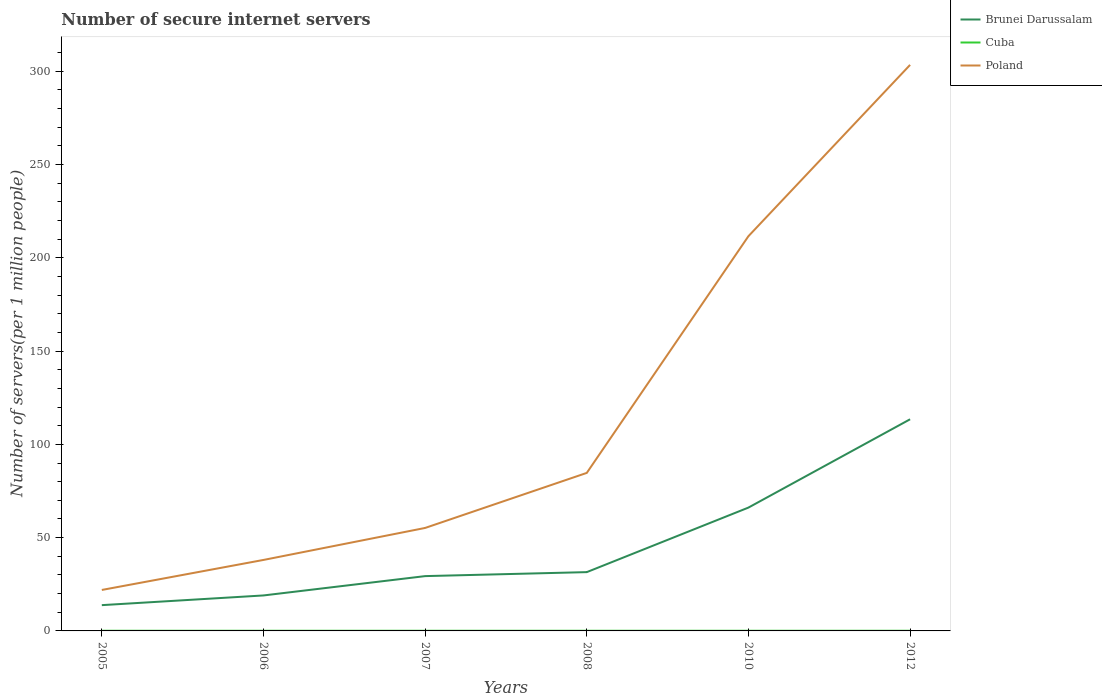Is the number of lines equal to the number of legend labels?
Give a very brief answer. Yes. Across all years, what is the maximum number of secure internet servers in Cuba?
Ensure brevity in your answer.  0.09. In which year was the number of secure internet servers in Brunei Darussalam maximum?
Offer a very short reply. 2005. What is the total number of secure internet servers in Poland in the graph?
Give a very brief answer. -91.81. What is the difference between the highest and the second highest number of secure internet servers in Brunei Darussalam?
Ensure brevity in your answer.  99.62. What is the difference between the highest and the lowest number of secure internet servers in Cuba?
Ensure brevity in your answer.  4. Is the number of secure internet servers in Cuba strictly greater than the number of secure internet servers in Poland over the years?
Ensure brevity in your answer.  Yes. Does the graph contain any zero values?
Provide a succinct answer. No. Where does the legend appear in the graph?
Ensure brevity in your answer.  Top right. How are the legend labels stacked?
Ensure brevity in your answer.  Vertical. What is the title of the graph?
Offer a terse response. Number of secure internet servers. What is the label or title of the X-axis?
Make the answer very short. Years. What is the label or title of the Y-axis?
Ensure brevity in your answer.  Number of servers(per 1 million people). What is the Number of servers(per 1 million people) of Brunei Darussalam in 2005?
Provide a succinct answer. 13.82. What is the Number of servers(per 1 million people) in Cuba in 2005?
Give a very brief answer. 0.09. What is the Number of servers(per 1 million people) of Poland in 2005?
Your response must be concise. 21.96. What is the Number of servers(per 1 million people) in Brunei Darussalam in 2006?
Your answer should be compact. 19.01. What is the Number of servers(per 1 million people) in Cuba in 2006?
Provide a short and direct response. 0.09. What is the Number of servers(per 1 million people) in Poland in 2006?
Ensure brevity in your answer.  38.04. What is the Number of servers(per 1 million people) of Brunei Darussalam in 2007?
Ensure brevity in your answer.  29.38. What is the Number of servers(per 1 million people) in Cuba in 2007?
Offer a very short reply. 0.09. What is the Number of servers(per 1 million people) of Poland in 2007?
Your answer should be very brief. 55.19. What is the Number of servers(per 1 million people) in Brunei Darussalam in 2008?
Your answer should be very brief. 31.51. What is the Number of servers(per 1 million people) in Cuba in 2008?
Make the answer very short. 0.09. What is the Number of servers(per 1 million people) of Poland in 2008?
Give a very brief answer. 84.69. What is the Number of servers(per 1 million people) of Brunei Darussalam in 2010?
Ensure brevity in your answer.  66.11. What is the Number of servers(per 1 million people) of Cuba in 2010?
Offer a terse response. 0.09. What is the Number of servers(per 1 million people) in Poland in 2010?
Keep it short and to the point. 211.58. What is the Number of servers(per 1 million people) of Brunei Darussalam in 2012?
Give a very brief answer. 113.44. What is the Number of servers(per 1 million people) of Cuba in 2012?
Your response must be concise. 0.09. What is the Number of servers(per 1 million people) of Poland in 2012?
Keep it short and to the point. 303.39. Across all years, what is the maximum Number of servers(per 1 million people) in Brunei Darussalam?
Keep it short and to the point. 113.44. Across all years, what is the maximum Number of servers(per 1 million people) in Cuba?
Offer a terse response. 0.09. Across all years, what is the maximum Number of servers(per 1 million people) in Poland?
Provide a succinct answer. 303.39. Across all years, what is the minimum Number of servers(per 1 million people) in Brunei Darussalam?
Keep it short and to the point. 13.82. Across all years, what is the minimum Number of servers(per 1 million people) of Cuba?
Provide a short and direct response. 0.09. Across all years, what is the minimum Number of servers(per 1 million people) of Poland?
Offer a very short reply. 21.96. What is the total Number of servers(per 1 million people) of Brunei Darussalam in the graph?
Offer a terse response. 273.26. What is the total Number of servers(per 1 million people) in Cuba in the graph?
Your response must be concise. 0.53. What is the total Number of servers(per 1 million people) of Poland in the graph?
Your answer should be compact. 714.85. What is the difference between the Number of servers(per 1 million people) of Brunei Darussalam in 2005 and that in 2006?
Provide a short and direct response. -5.2. What is the difference between the Number of servers(per 1 million people) in Cuba in 2005 and that in 2006?
Offer a very short reply. 0. What is the difference between the Number of servers(per 1 million people) in Poland in 2005 and that in 2006?
Keep it short and to the point. -16.09. What is the difference between the Number of servers(per 1 million people) in Brunei Darussalam in 2005 and that in 2007?
Provide a short and direct response. -15.56. What is the difference between the Number of servers(per 1 million people) in Cuba in 2005 and that in 2007?
Ensure brevity in your answer.  0. What is the difference between the Number of servers(per 1 million people) in Poland in 2005 and that in 2007?
Your answer should be compact. -33.24. What is the difference between the Number of servers(per 1 million people) in Brunei Darussalam in 2005 and that in 2008?
Keep it short and to the point. -17.7. What is the difference between the Number of servers(per 1 million people) of Cuba in 2005 and that in 2008?
Your answer should be compact. 0. What is the difference between the Number of servers(per 1 million people) of Poland in 2005 and that in 2008?
Make the answer very short. -62.74. What is the difference between the Number of servers(per 1 million people) in Brunei Darussalam in 2005 and that in 2010?
Your answer should be compact. -52.29. What is the difference between the Number of servers(per 1 million people) of Poland in 2005 and that in 2010?
Offer a very short reply. -189.62. What is the difference between the Number of servers(per 1 million people) of Brunei Darussalam in 2005 and that in 2012?
Your answer should be compact. -99.62. What is the difference between the Number of servers(per 1 million people) in Cuba in 2005 and that in 2012?
Your answer should be compact. 0. What is the difference between the Number of servers(per 1 million people) of Poland in 2005 and that in 2012?
Your answer should be very brief. -281.43. What is the difference between the Number of servers(per 1 million people) in Brunei Darussalam in 2006 and that in 2007?
Make the answer very short. -10.36. What is the difference between the Number of servers(per 1 million people) in Poland in 2006 and that in 2007?
Provide a short and direct response. -17.15. What is the difference between the Number of servers(per 1 million people) of Brunei Darussalam in 2006 and that in 2008?
Provide a succinct answer. -12.5. What is the difference between the Number of servers(per 1 million people) of Poland in 2006 and that in 2008?
Offer a terse response. -46.65. What is the difference between the Number of servers(per 1 million people) of Brunei Darussalam in 2006 and that in 2010?
Make the answer very short. -47.09. What is the difference between the Number of servers(per 1 million people) of Cuba in 2006 and that in 2010?
Your response must be concise. 0. What is the difference between the Number of servers(per 1 million people) of Poland in 2006 and that in 2010?
Your answer should be very brief. -173.53. What is the difference between the Number of servers(per 1 million people) in Brunei Darussalam in 2006 and that in 2012?
Give a very brief answer. -94.42. What is the difference between the Number of servers(per 1 million people) of Poland in 2006 and that in 2012?
Ensure brevity in your answer.  -265.35. What is the difference between the Number of servers(per 1 million people) in Brunei Darussalam in 2007 and that in 2008?
Your response must be concise. -2.14. What is the difference between the Number of servers(per 1 million people) of Cuba in 2007 and that in 2008?
Keep it short and to the point. 0. What is the difference between the Number of servers(per 1 million people) of Poland in 2007 and that in 2008?
Keep it short and to the point. -29.5. What is the difference between the Number of servers(per 1 million people) of Brunei Darussalam in 2007 and that in 2010?
Your answer should be very brief. -36.73. What is the difference between the Number of servers(per 1 million people) of Poland in 2007 and that in 2010?
Your response must be concise. -156.38. What is the difference between the Number of servers(per 1 million people) in Brunei Darussalam in 2007 and that in 2012?
Offer a terse response. -84.06. What is the difference between the Number of servers(per 1 million people) of Poland in 2007 and that in 2012?
Ensure brevity in your answer.  -248.2. What is the difference between the Number of servers(per 1 million people) in Brunei Darussalam in 2008 and that in 2010?
Provide a short and direct response. -34.59. What is the difference between the Number of servers(per 1 million people) in Cuba in 2008 and that in 2010?
Keep it short and to the point. 0. What is the difference between the Number of servers(per 1 million people) of Poland in 2008 and that in 2010?
Ensure brevity in your answer.  -126.88. What is the difference between the Number of servers(per 1 million people) in Brunei Darussalam in 2008 and that in 2012?
Ensure brevity in your answer.  -81.92. What is the difference between the Number of servers(per 1 million people) in Poland in 2008 and that in 2012?
Ensure brevity in your answer.  -218.7. What is the difference between the Number of servers(per 1 million people) of Brunei Darussalam in 2010 and that in 2012?
Your answer should be compact. -47.33. What is the difference between the Number of servers(per 1 million people) in Cuba in 2010 and that in 2012?
Your response must be concise. 0. What is the difference between the Number of servers(per 1 million people) of Poland in 2010 and that in 2012?
Make the answer very short. -91.81. What is the difference between the Number of servers(per 1 million people) in Brunei Darussalam in 2005 and the Number of servers(per 1 million people) in Cuba in 2006?
Give a very brief answer. 13.73. What is the difference between the Number of servers(per 1 million people) of Brunei Darussalam in 2005 and the Number of servers(per 1 million people) of Poland in 2006?
Give a very brief answer. -24.23. What is the difference between the Number of servers(per 1 million people) of Cuba in 2005 and the Number of servers(per 1 million people) of Poland in 2006?
Offer a very short reply. -37.95. What is the difference between the Number of servers(per 1 million people) in Brunei Darussalam in 2005 and the Number of servers(per 1 million people) in Cuba in 2007?
Offer a terse response. 13.73. What is the difference between the Number of servers(per 1 million people) of Brunei Darussalam in 2005 and the Number of servers(per 1 million people) of Poland in 2007?
Provide a short and direct response. -41.38. What is the difference between the Number of servers(per 1 million people) of Cuba in 2005 and the Number of servers(per 1 million people) of Poland in 2007?
Give a very brief answer. -55.1. What is the difference between the Number of servers(per 1 million people) in Brunei Darussalam in 2005 and the Number of servers(per 1 million people) in Cuba in 2008?
Your answer should be very brief. 13.73. What is the difference between the Number of servers(per 1 million people) in Brunei Darussalam in 2005 and the Number of servers(per 1 million people) in Poland in 2008?
Provide a succinct answer. -70.88. What is the difference between the Number of servers(per 1 million people) in Cuba in 2005 and the Number of servers(per 1 million people) in Poland in 2008?
Offer a terse response. -84.6. What is the difference between the Number of servers(per 1 million people) in Brunei Darussalam in 2005 and the Number of servers(per 1 million people) in Cuba in 2010?
Provide a short and direct response. 13.73. What is the difference between the Number of servers(per 1 million people) in Brunei Darussalam in 2005 and the Number of servers(per 1 million people) in Poland in 2010?
Ensure brevity in your answer.  -197.76. What is the difference between the Number of servers(per 1 million people) of Cuba in 2005 and the Number of servers(per 1 million people) of Poland in 2010?
Provide a short and direct response. -211.49. What is the difference between the Number of servers(per 1 million people) of Brunei Darussalam in 2005 and the Number of servers(per 1 million people) of Cuba in 2012?
Your response must be concise. 13.73. What is the difference between the Number of servers(per 1 million people) of Brunei Darussalam in 2005 and the Number of servers(per 1 million people) of Poland in 2012?
Ensure brevity in your answer.  -289.57. What is the difference between the Number of servers(per 1 million people) of Cuba in 2005 and the Number of servers(per 1 million people) of Poland in 2012?
Provide a succinct answer. -303.3. What is the difference between the Number of servers(per 1 million people) in Brunei Darussalam in 2006 and the Number of servers(per 1 million people) in Cuba in 2007?
Offer a terse response. 18.93. What is the difference between the Number of servers(per 1 million people) in Brunei Darussalam in 2006 and the Number of servers(per 1 million people) in Poland in 2007?
Your answer should be very brief. -36.18. What is the difference between the Number of servers(per 1 million people) in Cuba in 2006 and the Number of servers(per 1 million people) in Poland in 2007?
Provide a short and direct response. -55.1. What is the difference between the Number of servers(per 1 million people) in Brunei Darussalam in 2006 and the Number of servers(per 1 million people) in Cuba in 2008?
Provide a succinct answer. 18.93. What is the difference between the Number of servers(per 1 million people) of Brunei Darussalam in 2006 and the Number of servers(per 1 million people) of Poland in 2008?
Give a very brief answer. -65.68. What is the difference between the Number of servers(per 1 million people) of Cuba in 2006 and the Number of servers(per 1 million people) of Poland in 2008?
Provide a succinct answer. -84.6. What is the difference between the Number of servers(per 1 million people) in Brunei Darussalam in 2006 and the Number of servers(per 1 million people) in Cuba in 2010?
Keep it short and to the point. 18.93. What is the difference between the Number of servers(per 1 million people) of Brunei Darussalam in 2006 and the Number of servers(per 1 million people) of Poland in 2010?
Your response must be concise. -192.56. What is the difference between the Number of servers(per 1 million people) in Cuba in 2006 and the Number of servers(per 1 million people) in Poland in 2010?
Provide a short and direct response. -211.49. What is the difference between the Number of servers(per 1 million people) of Brunei Darussalam in 2006 and the Number of servers(per 1 million people) of Cuba in 2012?
Make the answer very short. 18.93. What is the difference between the Number of servers(per 1 million people) in Brunei Darussalam in 2006 and the Number of servers(per 1 million people) in Poland in 2012?
Keep it short and to the point. -284.38. What is the difference between the Number of servers(per 1 million people) in Cuba in 2006 and the Number of servers(per 1 million people) in Poland in 2012?
Make the answer very short. -303.3. What is the difference between the Number of servers(per 1 million people) of Brunei Darussalam in 2007 and the Number of servers(per 1 million people) of Cuba in 2008?
Your answer should be compact. 29.29. What is the difference between the Number of servers(per 1 million people) of Brunei Darussalam in 2007 and the Number of servers(per 1 million people) of Poland in 2008?
Your answer should be very brief. -55.32. What is the difference between the Number of servers(per 1 million people) in Cuba in 2007 and the Number of servers(per 1 million people) in Poland in 2008?
Keep it short and to the point. -84.6. What is the difference between the Number of servers(per 1 million people) in Brunei Darussalam in 2007 and the Number of servers(per 1 million people) in Cuba in 2010?
Offer a terse response. 29.29. What is the difference between the Number of servers(per 1 million people) of Brunei Darussalam in 2007 and the Number of servers(per 1 million people) of Poland in 2010?
Provide a succinct answer. -182.2. What is the difference between the Number of servers(per 1 million people) of Cuba in 2007 and the Number of servers(per 1 million people) of Poland in 2010?
Your response must be concise. -211.49. What is the difference between the Number of servers(per 1 million people) of Brunei Darussalam in 2007 and the Number of servers(per 1 million people) of Cuba in 2012?
Ensure brevity in your answer.  29.29. What is the difference between the Number of servers(per 1 million people) of Brunei Darussalam in 2007 and the Number of servers(per 1 million people) of Poland in 2012?
Keep it short and to the point. -274.01. What is the difference between the Number of servers(per 1 million people) in Cuba in 2007 and the Number of servers(per 1 million people) in Poland in 2012?
Provide a succinct answer. -303.3. What is the difference between the Number of servers(per 1 million people) of Brunei Darussalam in 2008 and the Number of servers(per 1 million people) of Cuba in 2010?
Keep it short and to the point. 31.43. What is the difference between the Number of servers(per 1 million people) in Brunei Darussalam in 2008 and the Number of servers(per 1 million people) in Poland in 2010?
Give a very brief answer. -180.06. What is the difference between the Number of servers(per 1 million people) in Cuba in 2008 and the Number of servers(per 1 million people) in Poland in 2010?
Provide a succinct answer. -211.49. What is the difference between the Number of servers(per 1 million people) of Brunei Darussalam in 2008 and the Number of servers(per 1 million people) of Cuba in 2012?
Your answer should be very brief. 31.43. What is the difference between the Number of servers(per 1 million people) of Brunei Darussalam in 2008 and the Number of servers(per 1 million people) of Poland in 2012?
Provide a short and direct response. -271.88. What is the difference between the Number of servers(per 1 million people) of Cuba in 2008 and the Number of servers(per 1 million people) of Poland in 2012?
Your answer should be very brief. -303.3. What is the difference between the Number of servers(per 1 million people) in Brunei Darussalam in 2010 and the Number of servers(per 1 million people) in Cuba in 2012?
Offer a terse response. 66.02. What is the difference between the Number of servers(per 1 million people) in Brunei Darussalam in 2010 and the Number of servers(per 1 million people) in Poland in 2012?
Your answer should be very brief. -237.28. What is the difference between the Number of servers(per 1 million people) of Cuba in 2010 and the Number of servers(per 1 million people) of Poland in 2012?
Ensure brevity in your answer.  -303.3. What is the average Number of servers(per 1 million people) of Brunei Darussalam per year?
Offer a terse response. 45.54. What is the average Number of servers(per 1 million people) of Cuba per year?
Your answer should be compact. 0.09. What is the average Number of servers(per 1 million people) in Poland per year?
Keep it short and to the point. 119.14. In the year 2005, what is the difference between the Number of servers(per 1 million people) of Brunei Darussalam and Number of servers(per 1 million people) of Cuba?
Keep it short and to the point. 13.73. In the year 2005, what is the difference between the Number of servers(per 1 million people) of Brunei Darussalam and Number of servers(per 1 million people) of Poland?
Your answer should be compact. -8.14. In the year 2005, what is the difference between the Number of servers(per 1 million people) of Cuba and Number of servers(per 1 million people) of Poland?
Provide a succinct answer. -21.87. In the year 2006, what is the difference between the Number of servers(per 1 million people) of Brunei Darussalam and Number of servers(per 1 million people) of Cuba?
Provide a succinct answer. 18.93. In the year 2006, what is the difference between the Number of servers(per 1 million people) in Brunei Darussalam and Number of servers(per 1 million people) in Poland?
Your answer should be compact. -19.03. In the year 2006, what is the difference between the Number of servers(per 1 million people) of Cuba and Number of servers(per 1 million people) of Poland?
Ensure brevity in your answer.  -37.95. In the year 2007, what is the difference between the Number of servers(per 1 million people) of Brunei Darussalam and Number of servers(per 1 million people) of Cuba?
Your answer should be very brief. 29.29. In the year 2007, what is the difference between the Number of servers(per 1 million people) in Brunei Darussalam and Number of servers(per 1 million people) in Poland?
Provide a succinct answer. -25.82. In the year 2007, what is the difference between the Number of servers(per 1 million people) in Cuba and Number of servers(per 1 million people) in Poland?
Make the answer very short. -55.1. In the year 2008, what is the difference between the Number of servers(per 1 million people) of Brunei Darussalam and Number of servers(per 1 million people) of Cuba?
Your answer should be compact. 31.43. In the year 2008, what is the difference between the Number of servers(per 1 million people) of Brunei Darussalam and Number of servers(per 1 million people) of Poland?
Your response must be concise. -53.18. In the year 2008, what is the difference between the Number of servers(per 1 million people) of Cuba and Number of servers(per 1 million people) of Poland?
Give a very brief answer. -84.6. In the year 2010, what is the difference between the Number of servers(per 1 million people) of Brunei Darussalam and Number of servers(per 1 million people) of Cuba?
Offer a very short reply. 66.02. In the year 2010, what is the difference between the Number of servers(per 1 million people) in Brunei Darussalam and Number of servers(per 1 million people) in Poland?
Keep it short and to the point. -145.47. In the year 2010, what is the difference between the Number of servers(per 1 million people) of Cuba and Number of servers(per 1 million people) of Poland?
Your answer should be very brief. -211.49. In the year 2012, what is the difference between the Number of servers(per 1 million people) of Brunei Darussalam and Number of servers(per 1 million people) of Cuba?
Offer a very short reply. 113.35. In the year 2012, what is the difference between the Number of servers(per 1 million people) in Brunei Darussalam and Number of servers(per 1 million people) in Poland?
Offer a very short reply. -189.95. In the year 2012, what is the difference between the Number of servers(per 1 million people) of Cuba and Number of servers(per 1 million people) of Poland?
Your answer should be very brief. -303.3. What is the ratio of the Number of servers(per 1 million people) in Brunei Darussalam in 2005 to that in 2006?
Your answer should be compact. 0.73. What is the ratio of the Number of servers(per 1 million people) of Cuba in 2005 to that in 2006?
Give a very brief answer. 1. What is the ratio of the Number of servers(per 1 million people) in Poland in 2005 to that in 2006?
Provide a short and direct response. 0.58. What is the ratio of the Number of servers(per 1 million people) of Brunei Darussalam in 2005 to that in 2007?
Give a very brief answer. 0.47. What is the ratio of the Number of servers(per 1 million people) in Poland in 2005 to that in 2007?
Your answer should be very brief. 0.4. What is the ratio of the Number of servers(per 1 million people) of Brunei Darussalam in 2005 to that in 2008?
Give a very brief answer. 0.44. What is the ratio of the Number of servers(per 1 million people) of Cuba in 2005 to that in 2008?
Offer a very short reply. 1. What is the ratio of the Number of servers(per 1 million people) in Poland in 2005 to that in 2008?
Provide a succinct answer. 0.26. What is the ratio of the Number of servers(per 1 million people) in Brunei Darussalam in 2005 to that in 2010?
Keep it short and to the point. 0.21. What is the ratio of the Number of servers(per 1 million people) in Cuba in 2005 to that in 2010?
Give a very brief answer. 1. What is the ratio of the Number of servers(per 1 million people) of Poland in 2005 to that in 2010?
Ensure brevity in your answer.  0.1. What is the ratio of the Number of servers(per 1 million people) in Brunei Darussalam in 2005 to that in 2012?
Offer a very short reply. 0.12. What is the ratio of the Number of servers(per 1 million people) in Cuba in 2005 to that in 2012?
Your answer should be compact. 1.01. What is the ratio of the Number of servers(per 1 million people) in Poland in 2005 to that in 2012?
Provide a succinct answer. 0.07. What is the ratio of the Number of servers(per 1 million people) of Brunei Darussalam in 2006 to that in 2007?
Provide a short and direct response. 0.65. What is the ratio of the Number of servers(per 1 million people) of Cuba in 2006 to that in 2007?
Offer a terse response. 1. What is the ratio of the Number of servers(per 1 million people) in Poland in 2006 to that in 2007?
Offer a very short reply. 0.69. What is the ratio of the Number of servers(per 1 million people) of Brunei Darussalam in 2006 to that in 2008?
Your answer should be compact. 0.6. What is the ratio of the Number of servers(per 1 million people) of Poland in 2006 to that in 2008?
Ensure brevity in your answer.  0.45. What is the ratio of the Number of servers(per 1 million people) of Brunei Darussalam in 2006 to that in 2010?
Your response must be concise. 0.29. What is the ratio of the Number of servers(per 1 million people) of Poland in 2006 to that in 2010?
Offer a terse response. 0.18. What is the ratio of the Number of servers(per 1 million people) of Brunei Darussalam in 2006 to that in 2012?
Keep it short and to the point. 0.17. What is the ratio of the Number of servers(per 1 million people) in Cuba in 2006 to that in 2012?
Give a very brief answer. 1.01. What is the ratio of the Number of servers(per 1 million people) in Poland in 2006 to that in 2012?
Your answer should be compact. 0.13. What is the ratio of the Number of servers(per 1 million people) in Brunei Darussalam in 2007 to that in 2008?
Your response must be concise. 0.93. What is the ratio of the Number of servers(per 1 million people) in Cuba in 2007 to that in 2008?
Provide a succinct answer. 1. What is the ratio of the Number of servers(per 1 million people) in Poland in 2007 to that in 2008?
Ensure brevity in your answer.  0.65. What is the ratio of the Number of servers(per 1 million people) in Brunei Darussalam in 2007 to that in 2010?
Offer a terse response. 0.44. What is the ratio of the Number of servers(per 1 million people) in Poland in 2007 to that in 2010?
Make the answer very short. 0.26. What is the ratio of the Number of servers(per 1 million people) in Brunei Darussalam in 2007 to that in 2012?
Offer a terse response. 0.26. What is the ratio of the Number of servers(per 1 million people) in Poland in 2007 to that in 2012?
Your answer should be very brief. 0.18. What is the ratio of the Number of servers(per 1 million people) in Brunei Darussalam in 2008 to that in 2010?
Keep it short and to the point. 0.48. What is the ratio of the Number of servers(per 1 million people) in Cuba in 2008 to that in 2010?
Your answer should be very brief. 1. What is the ratio of the Number of servers(per 1 million people) of Poland in 2008 to that in 2010?
Your response must be concise. 0.4. What is the ratio of the Number of servers(per 1 million people) in Brunei Darussalam in 2008 to that in 2012?
Your response must be concise. 0.28. What is the ratio of the Number of servers(per 1 million people) of Poland in 2008 to that in 2012?
Provide a succinct answer. 0.28. What is the ratio of the Number of servers(per 1 million people) in Brunei Darussalam in 2010 to that in 2012?
Keep it short and to the point. 0.58. What is the ratio of the Number of servers(per 1 million people) of Cuba in 2010 to that in 2012?
Your answer should be very brief. 1. What is the ratio of the Number of servers(per 1 million people) in Poland in 2010 to that in 2012?
Provide a short and direct response. 0.7. What is the difference between the highest and the second highest Number of servers(per 1 million people) in Brunei Darussalam?
Provide a short and direct response. 47.33. What is the difference between the highest and the second highest Number of servers(per 1 million people) of Cuba?
Make the answer very short. 0. What is the difference between the highest and the second highest Number of servers(per 1 million people) in Poland?
Provide a succinct answer. 91.81. What is the difference between the highest and the lowest Number of servers(per 1 million people) in Brunei Darussalam?
Keep it short and to the point. 99.62. What is the difference between the highest and the lowest Number of servers(per 1 million people) in Cuba?
Provide a short and direct response. 0. What is the difference between the highest and the lowest Number of servers(per 1 million people) in Poland?
Your answer should be compact. 281.43. 